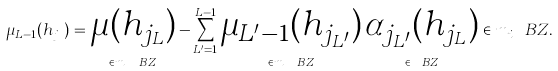Convert formula to latex. <formula><loc_0><loc_0><loc_500><loc_500>\mu _ { L - 1 } ( h _ { j _ { L } } ) = \underbrace { \mu ( h _ { j _ { L } } ) } _ { \in m _ { i } \ B Z } - \sum _ { L ^ { \prime } = 1 } ^ { L - 1 } \underbrace { \mu _ { L ^ { \prime } - 1 } ( h _ { j _ { L ^ { \prime } } } ) } _ { \in m _ { i } \ B Z } \underbrace { \alpha _ { j _ { L ^ { \prime } } } ( h _ { j _ { L } } ) } _ { \in \ B Z } \in m _ { i } \ B Z .</formula> 